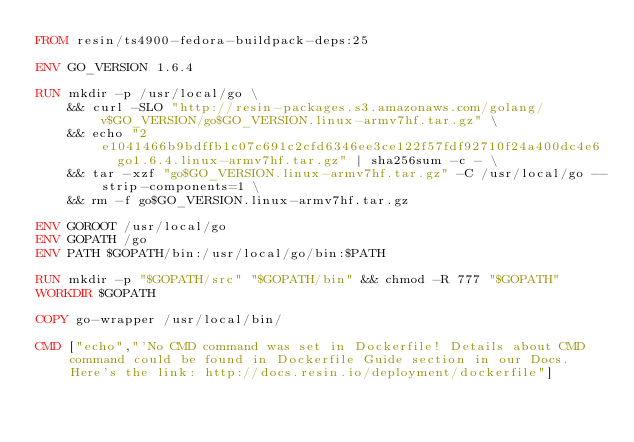<code> <loc_0><loc_0><loc_500><loc_500><_Dockerfile_>FROM resin/ts4900-fedora-buildpack-deps:25

ENV GO_VERSION 1.6.4

RUN mkdir -p /usr/local/go \
	&& curl -SLO "http://resin-packages.s3.amazonaws.com/golang/v$GO_VERSION/go$GO_VERSION.linux-armv7hf.tar.gz" \
	&& echo "2e1041466b9bdffb1c07c691c2cfd6346ee3ce122f57fdf92710f24a400dc4e6  go1.6.4.linux-armv7hf.tar.gz" | sha256sum -c - \
	&& tar -xzf "go$GO_VERSION.linux-armv7hf.tar.gz" -C /usr/local/go --strip-components=1 \
	&& rm -f go$GO_VERSION.linux-armv7hf.tar.gz

ENV GOROOT /usr/local/go
ENV GOPATH /go
ENV PATH $GOPATH/bin:/usr/local/go/bin:$PATH

RUN mkdir -p "$GOPATH/src" "$GOPATH/bin" && chmod -R 777 "$GOPATH"
WORKDIR $GOPATH

COPY go-wrapper /usr/local/bin/

CMD ["echo","'No CMD command was set in Dockerfile! Details about CMD command could be found in Dockerfile Guide section in our Docs. Here's the link: http://docs.resin.io/deployment/dockerfile"]
</code> 